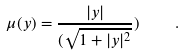<formula> <loc_0><loc_0><loc_500><loc_500>\mu ( y ) = \frac { | y | } { ( \sqrt { 1 + | y | ^ { 2 } } } ) \quad .</formula> 